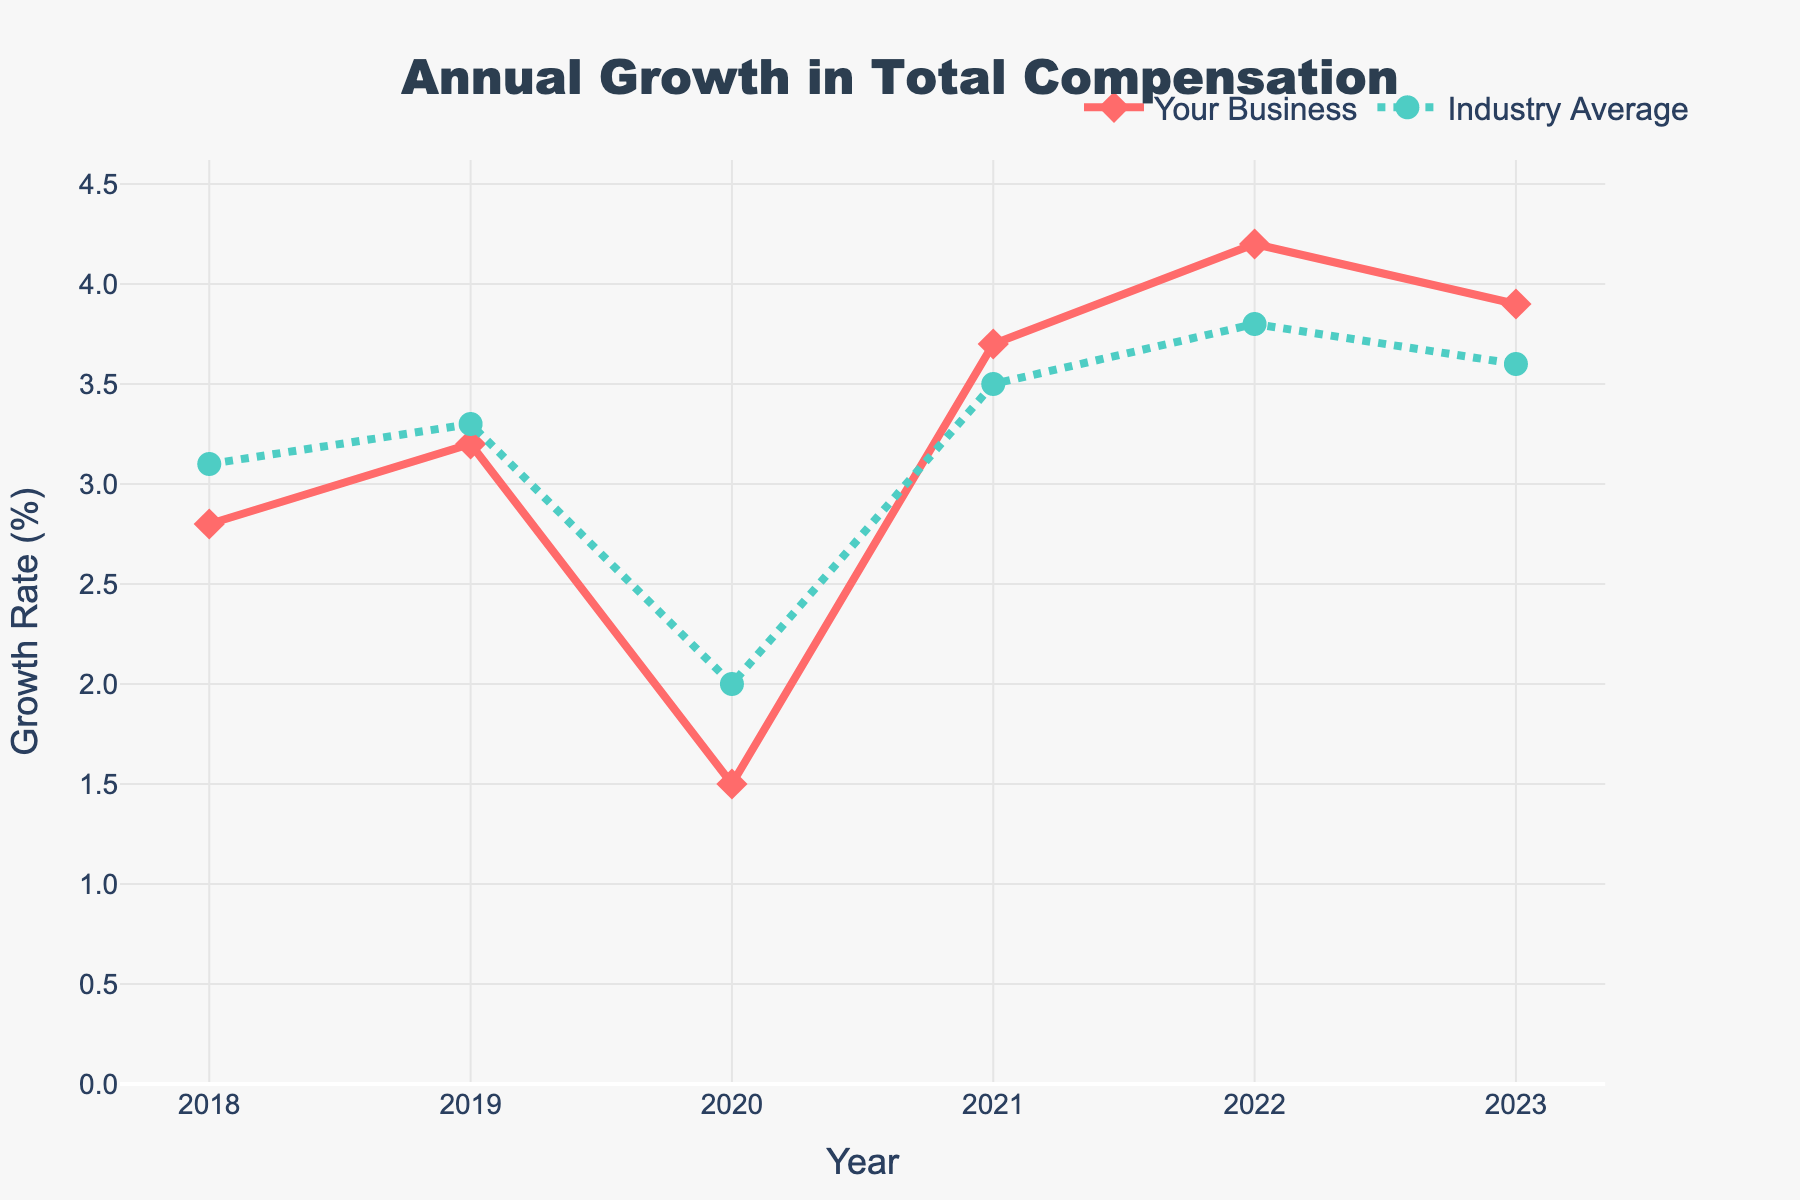What is the growth rate of your business in 2022? The growth rate of your business is represented by a red diamond. In 2022, the red diamond is positioned at 4.2 on the y-axis. Therefore, the growth rate of your business in 2022 is 4.2%.
Answer: 4.2% How does the 2021 growth rate of your business compare to the industry average growth rate that year? The growth rate of your business in 2021 is represented by the red diamond at 3.7, while the industry average is shown by the green circle at 3.5. Therefore, your business's growth rate in 2021 is 0.2% higher than the industry average.
Answer: 0.2% higher Which year had the biggest difference between your business’s growth rate and the industry average? By examining the differences each year:
- 2018: 2.8 - 3.1 = -0.3
- 2019: 3.2 - 3.3 = -0.1
- 2020: 1.5 - 2.0 = -0.5
- 2021: 3.7 - 3.5 = 0.2
- 2022: 4.2 - 3.8 = 0.4
- 2023: 3.9 - 3.6 = 0.3
The year 2020 has the biggest difference of -0.5%.
Answer: 2020 What is the trend in the growth rate for your business from 2018 to 2023? Observing the red diamonds, the growth rate for your business started at 2.8 in 2018, increased to 3.2 in 2019, dropped to 1.5 in 2020, rose again to 3.7 in 2021, peaked at 4.2 in 2022, and slightly decreased to 3.9 in 2023. Overall, it shows an upward trend with some fluctuations.
Answer: Upward trend with fluctuations Calculate the average growth rate for your business over the entire period. Sum the growth rates for your business: 2.8 + 3.2 + 1.5 + 3.7 + 4.2 + 3.9 = 19.3. Divide by the number of years (6): 19.3 / 6 ≈ 3.22%.
Answer: 3.22% In what year did your business experience the lowest growth rate and what was it? The lowest red diamond is at 1.5 on the y-axis in the year 2020. Therefore, the lowest growth rate was in 2020.
Answer: 2020, 1.5% How does the average growth rate of your business compare to the industry average over the entire period? Calculate the average growth rates:
- Your business: (2.8 + 3.2 + 1.5 + 3.7 + 4.2 + 3.9)/6 = 3.22%
- Industry: (3.1 + 3.3 + 2.0 + 3.5 + 3.8 + 3.6)/6 = 3.22%
Both averages are equal at 3.22%.
Answer: Equal, 3.22% What was the combined growth rate of your business and the industry average in 2021? Add the growth rates for your business and the industry average in 2021: 3.7 + 3.5 = 7.2%.
Answer: 7.2% In which years did your business's growth rate exceed the industry average? Check where the red diamond is above the green circle:
2019: 3.2 > 3.3 (No)
2021: 3.7 > 3.5 (Yes)
2022: 4.2 > 3.8 (Yes)
2023: 3.9 > 3.6 (Yes)
So, the years are 2021, 2022, and 2023.
Answer: 2021, 2022, 2023 